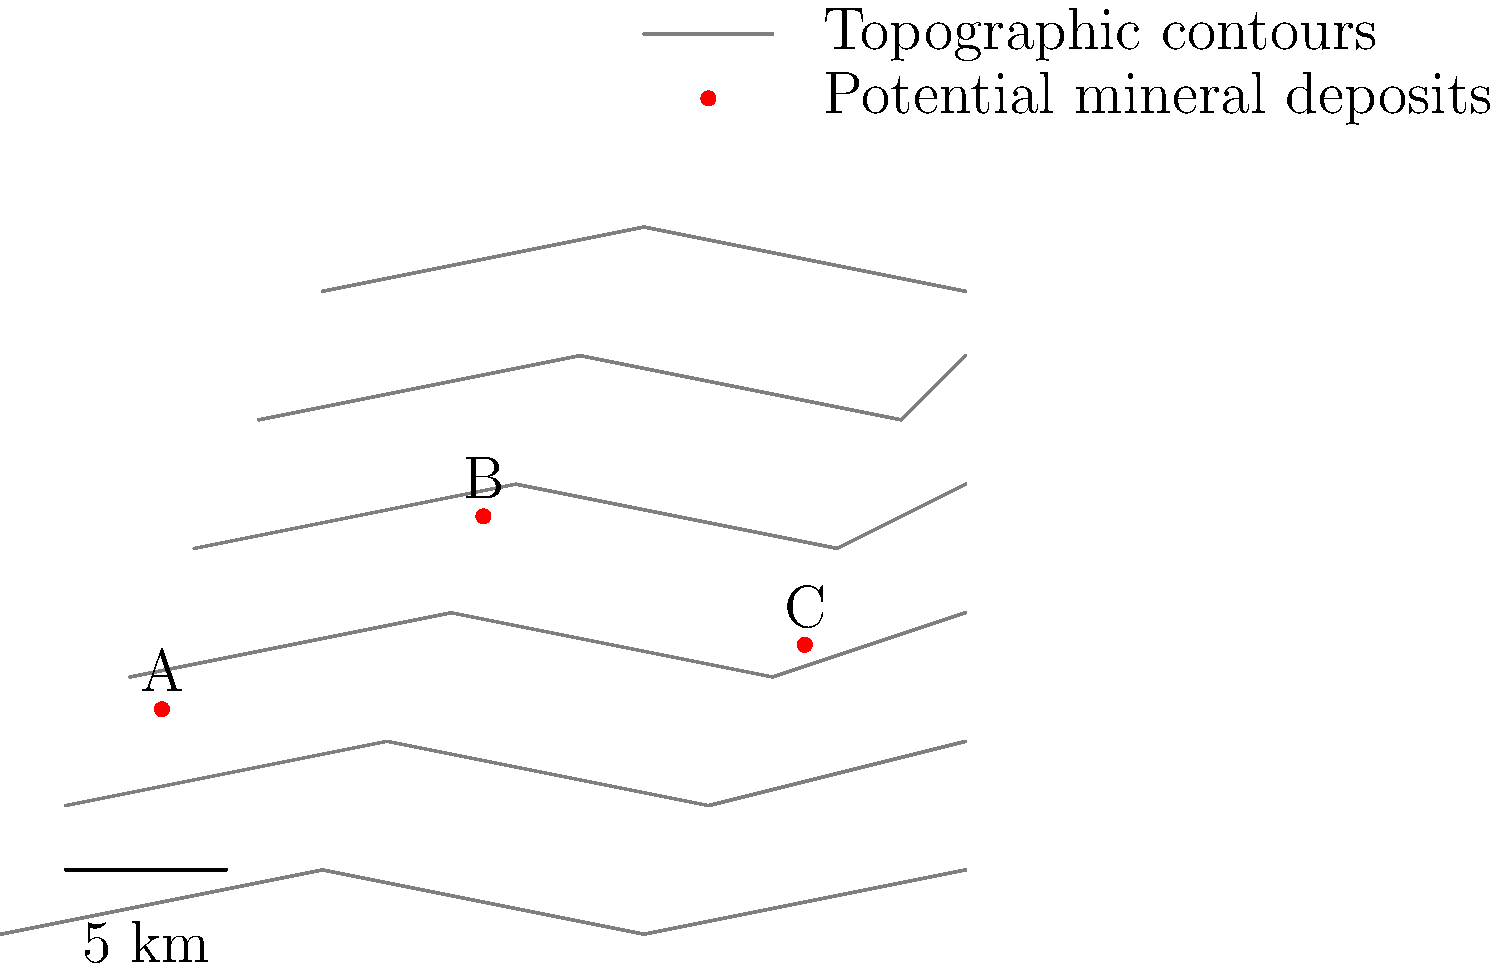Based on the topographic map showing potential mineral deposit locations A, B, and C, which location is most likely to have the highest concentration of minerals typically associated with orogenic gold deposits? To answer this question, we need to consider the characteristics of orogenic gold deposits and how they relate to topography:

1. Orogenic gold deposits are often associated with fault systems and shear zones in mountainous regions.

2. These deposits tend to form along structural weaknesses in the earth's crust, which can be indicated by abrupt changes in topography.

3. Areas with closely spaced contour lines indicate steeper terrain, which can be associated with fault systems.

4. Gold-bearing fluids often move upward through these fault systems, depositing gold in areas of sudden pressure changes.

Analyzing the map:

1. Location A is in an area with relatively widely spaced contour lines, indicating gentler slopes. This is less likely to be associated with major fault systems.

2. Location B is situated where the contour lines are closest together, indicating the steepest terrain. This suggests a possible fault or shear zone, which is favorable for orogenic gold deposits.

3. Location C is in an area with moderately spaced contour lines, indicating intermediate terrain steepness.

Based on this analysis, Location B is the most likely to have the highest concentration of minerals associated with orogenic gold deposits due to its position in the area of steepest terrain, which suggests the presence of fault systems or shear zones conducive to gold mineralization.
Answer: Location B 